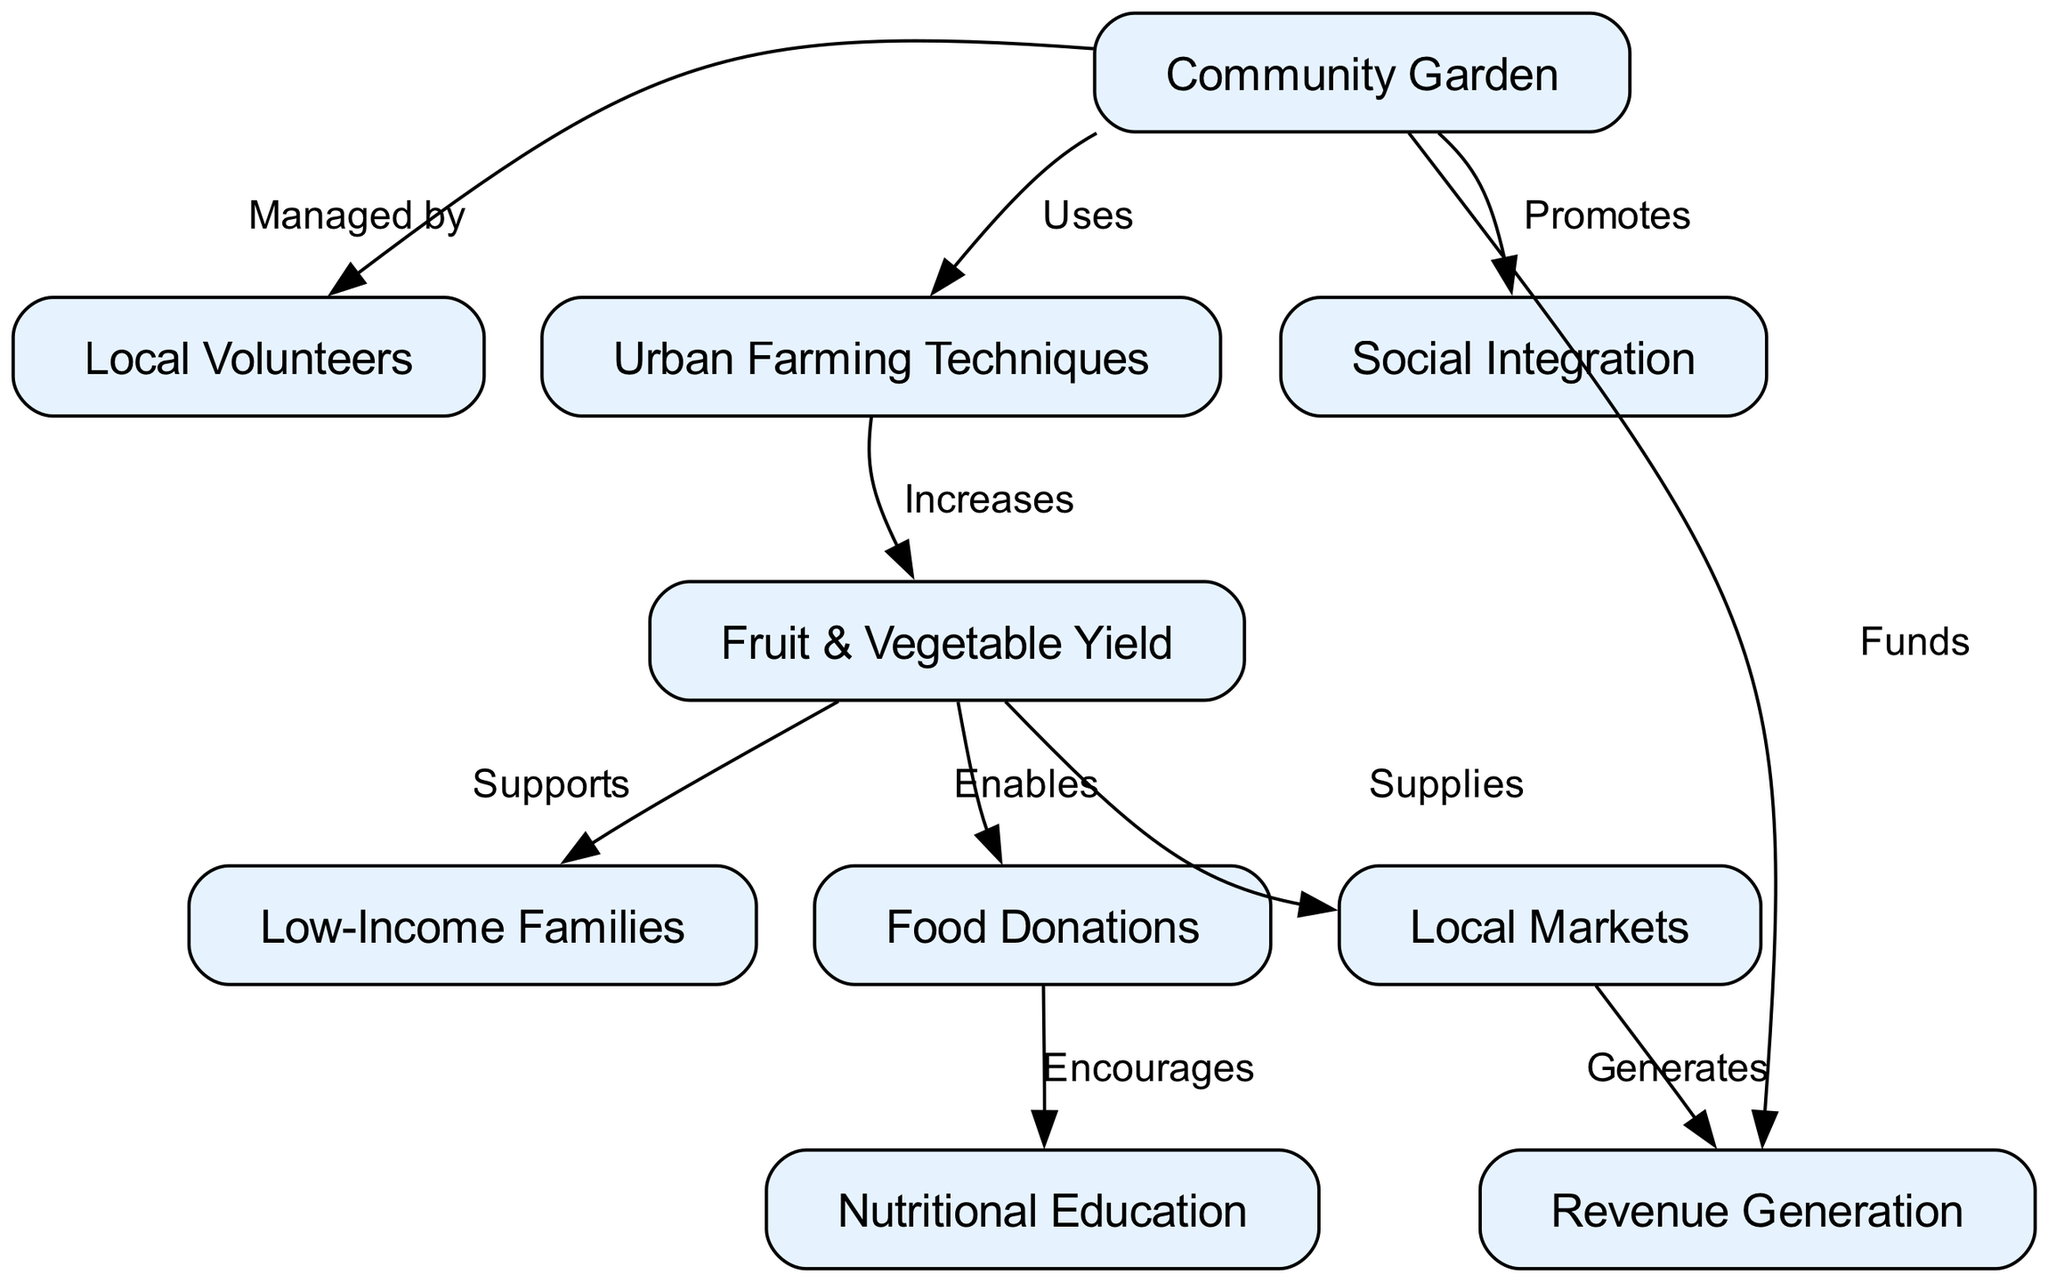What node is managed by local volunteers? The diagram indicates that the "Community Garden" node has an edge labeled "Managed by" pointing to the "Local Volunteers" node. This specifies that local volunteers are the ones responsible for managing community gardens.
Answer: Local Volunteers How many nodes are there in the diagram? By counting each distinct node in the provided data for the diagram, we can find that there are ten nodes in total: Community Garden, Local Volunteers, Urban Farming Techniques, Fruit & Vegetable Yield, Low-Income Families, Food Donations, Nutritional Education, Social Integration, Local Markets, and Revenue Generation.
Answer: 10 What relationship does the community garden promote? The diagram shows an edge pointing from "Community Garden" to "Social Integration" labeled "Promotes." This illustrates that the community garden plays a role in promoting social integration among community members.
Answer: Social Integration Which node supplies local markets? The diagram illustrates that the "Fruit & Vegetable Yield" node has an edge pointing to the "Local Markets" node with the label "Supplies." This means that the yield from community gardens provides produce to local markets.
Answer: Local Markets What encourages nutritional education according to the diagram? Tracing the flow from the "Food Donations" node, we see it has an edge connecting to the "Nutritional Education" node labeled "Encourages." This suggests that food donations made from community gardens support the promotion of nutritional education.
Answer: Food Donations What funds the community garden? According to the diagram, the edge from the "Revenue Generation" node points back to the "Community Garden" node with the label "Funds." This indicates that revenue generation helps finance the community gardens.
Answer: Revenue Generation What increases fruit and vegetable yield? The edge labeled "Increases" clearly connects the "Urban Farming Techniques" node to the "Fruit & Vegetable Yield" node, meaning these techniques lead to a higher yield of produce.
Answer: Urban Farming Techniques How many edges are there in the diagram? By counting each connection in the edges section of the data, we find there are nine distinct edges present in the diagram, representing relationships between the nodes.
Answer: 9 What enables food donations in the flow of the diagram? The "Fruit & Vegetable Yield" node has an edge pointing to "Food Donations" with the label "Enables," indicating that the yield from community gardens directly facilitates the possibility of food donations.
Answer: Fruit & Vegetable Yield 